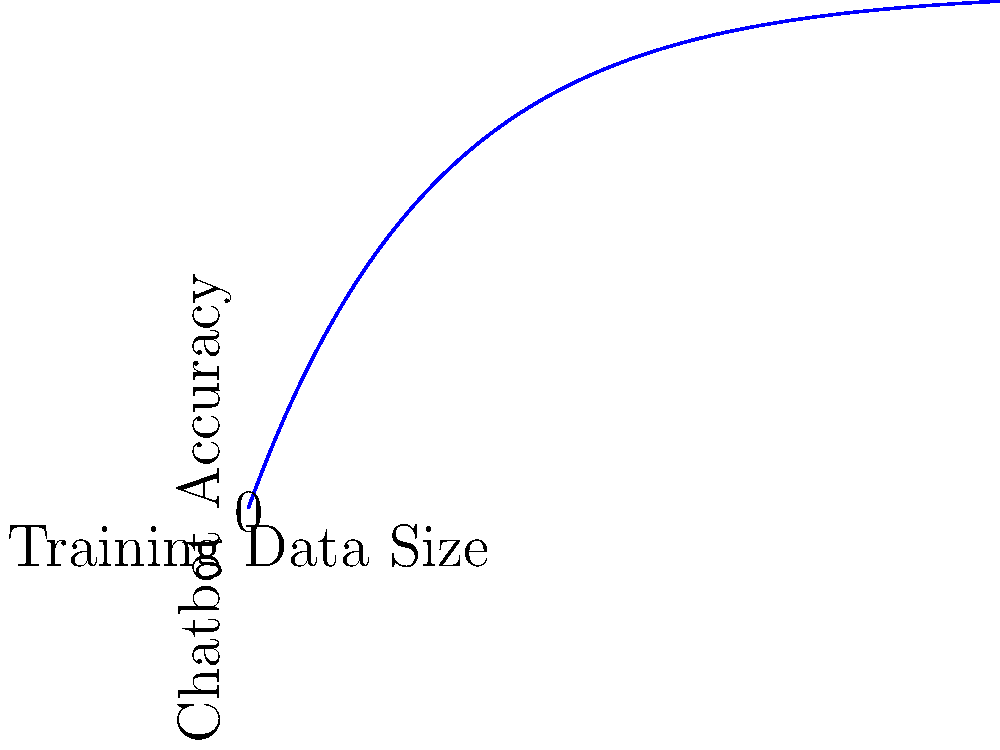Based on the graph showing the relationship between training data size and chatbot accuracy, what type of function best describes this relationship, and what does it imply about the impact of increasing training data on chatbot performance? To answer this question, let's analyze the graph step-by-step:

1. Shape of the curve: The graph shows a curve that starts with a steep increase and then gradually levels off as it approaches a horizontal asymptote.

2. Identifying the function type: This shape is characteristic of an exponential decay function, but in this case, it's inverted. The mathematical form of this function is typically:

   $$y = a(1 - e^{-bx})$$

   where $a$ is the horizontal asymptote and $b$ is the rate of growth.

3. Interpretation in context:
   - $x$-axis represents the training data size
   - $y$-axis represents the chatbot accuracy
   - As $x$ increases, $y$ approaches but never quite reaches the asymptote

4. Implication for chatbot performance:
   - Initially, small increases in training data size lead to significant improvements in accuracy.
   - As more data is added, the rate of improvement diminishes.
   - There's a point of diminishing returns where adding more data provides minimal accuracy gains.

5. In machine learning terms, this relationship is often referred to as a "learning curve" or "performance curve."

Therefore, the relationship is best described by a logarithmic or exponential growth function, implying that while increasing training data generally improves chatbot accuracy, the rate of improvement decreases as the dataset grows larger.
Answer: Logarithmic growth; diminishing returns on accuracy as training data increases 